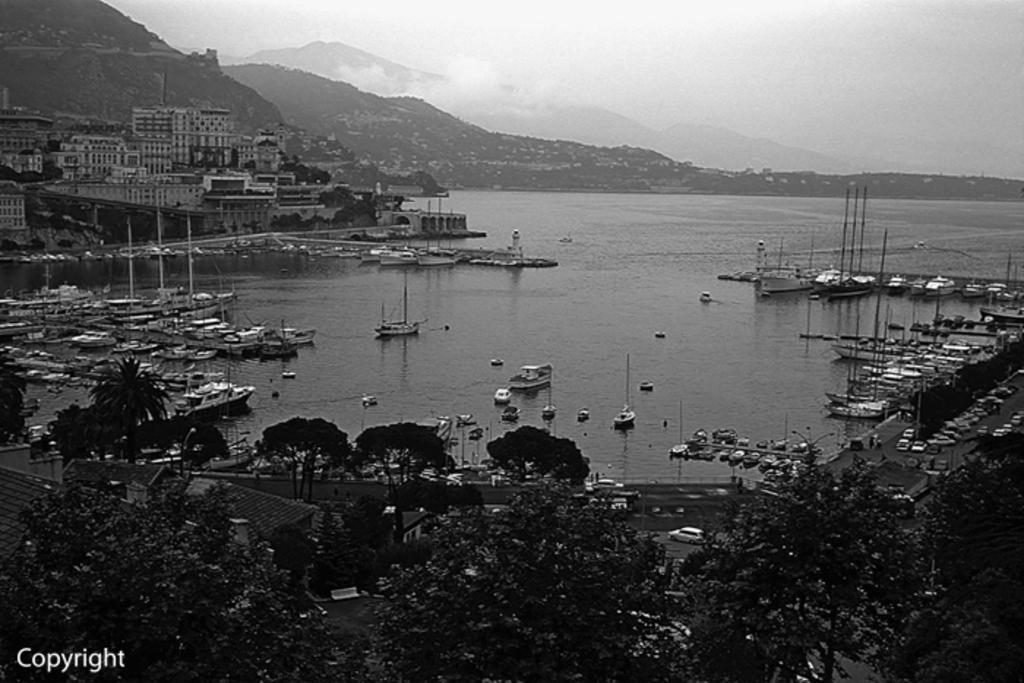Describe this image in one or two sentences. In this image I can see many vehicles on the road. On both sides of the road I can see many trees and poles. There are many boats on the water. In the background I can see the buildings, mountains and the sky. I can see this is a black and white image. 